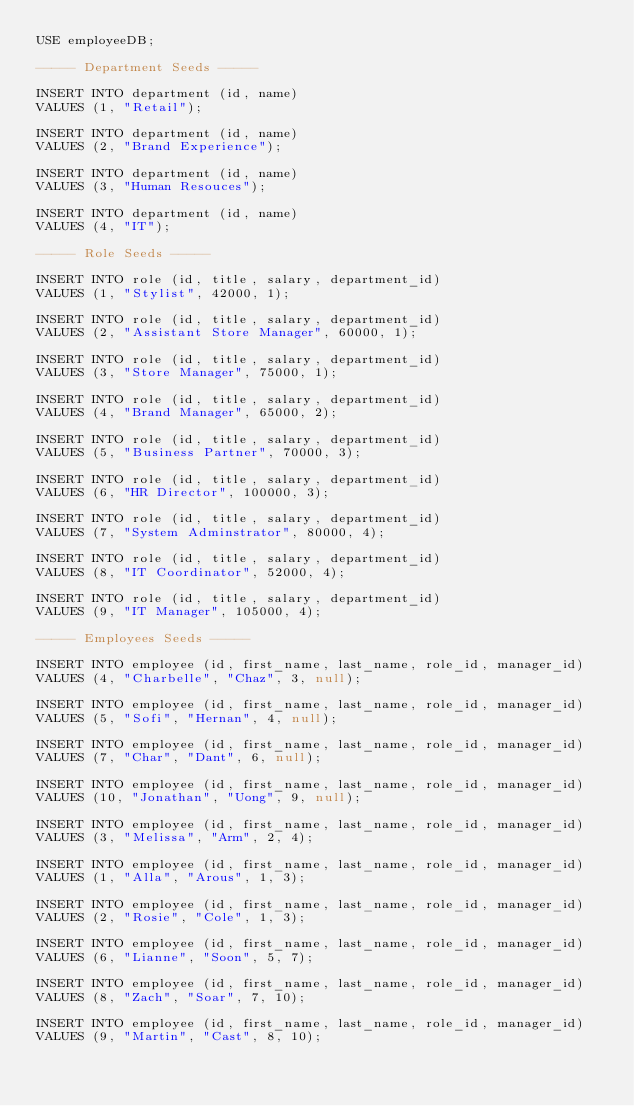Convert code to text. <code><loc_0><loc_0><loc_500><loc_500><_SQL_>USE employeeDB;

----- Department Seeds -----

INSERT INTO department (id, name)
VALUES (1, "Retail");

INSERT INTO department (id, name)
VALUES (2, "Brand Experience");

INSERT INTO department (id, name)
VALUES (3, "Human Resouces");

INSERT INTO department (id, name)
VALUES (4, "IT");

----- Role Seeds -----

INSERT INTO role (id, title, salary, department_id)
VALUES (1, "Stylist", 42000, 1);

INSERT INTO role (id, title, salary, department_id)
VALUES (2, "Assistant Store Manager", 60000, 1);

INSERT INTO role (id, title, salary, department_id)
VALUES (3, "Store Manager", 75000, 1);

INSERT INTO role (id, title, salary, department_id)
VALUES (4, "Brand Manager", 65000, 2);

INSERT INTO role (id, title, salary, department_id)
VALUES (5, "Business Partner", 70000, 3);

INSERT INTO role (id, title, salary, department_id)
VALUES (6, "HR Director", 100000, 3);

INSERT INTO role (id, title, salary, department_id)
VALUES (7, "System Adminstrator", 80000, 4);

INSERT INTO role (id, title, salary, department_id)
VALUES (8, "IT Coordinator", 52000, 4);

INSERT INTO role (id, title, salary, department_id)
VALUES (9, "IT Manager", 105000, 4);

----- Employees Seeds -----

INSERT INTO employee (id, first_name, last_name, role_id, manager_id)
VALUES (4, "Charbelle", "Chaz", 3, null);

INSERT INTO employee (id, first_name, last_name, role_id, manager_id)
VALUES (5, "Sofi", "Hernan", 4, null);

INSERT INTO employee (id, first_name, last_name, role_id, manager_id)
VALUES (7, "Char", "Dant", 6, null);

INSERT INTO employee (id, first_name, last_name, role_id, manager_id)
VALUES (10, "Jonathan", "Uong", 9, null);

INSERT INTO employee (id, first_name, last_name, role_id, manager_id)
VALUES (3, "Melissa", "Arm", 2, 4);

INSERT INTO employee (id, first_name, last_name, role_id, manager_id)
VALUES (1, "Alla", "Arous", 1, 3);

INSERT INTO employee (id, first_name, last_name, role_id, manager_id)
VALUES (2, "Rosie", "Cole", 1, 3);

INSERT INTO employee (id, first_name, last_name, role_id, manager_id)
VALUES (6, "Lianne", "Soon", 5, 7);

INSERT INTO employee (id, first_name, last_name, role_id, manager_id)
VALUES (8, "Zach", "Soar", 7, 10);

INSERT INTO employee (id, first_name, last_name, role_id, manager_id)
VALUES (9, "Martin", "Cast", 8, 10);
</code> 